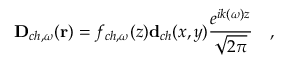Convert formula to latex. <formula><loc_0><loc_0><loc_500><loc_500>D _ { c h , \omega } ( r ) = f _ { c h , \omega } ( z ) d _ { c h } ( x , y ) \frac { e ^ { i k ( \omega ) z } } { \sqrt { 2 \pi } } \quad ,</formula> 